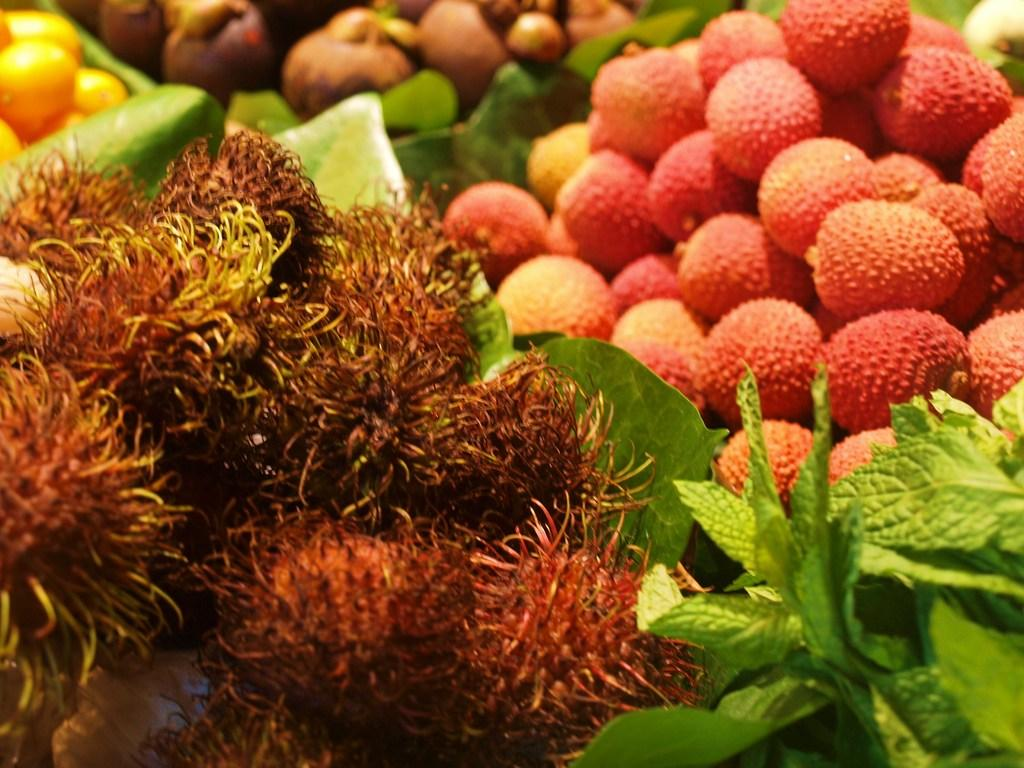What type of food items are present in the image? There are fruits in the image. What else can be seen in the image besides the fruits? There are leaves in the image. Can you describe the arrangement of the leaves in relation to the fruits? The leaves are in the middle of the fruits. What type of plantation can be seen in the image? There is no plantation present in the image; it only features fruits and leaves. What is the view like from the edge of the plantation in the image? There is no edge or view from a plantation in the image, as it only contains fruits and leaves. 